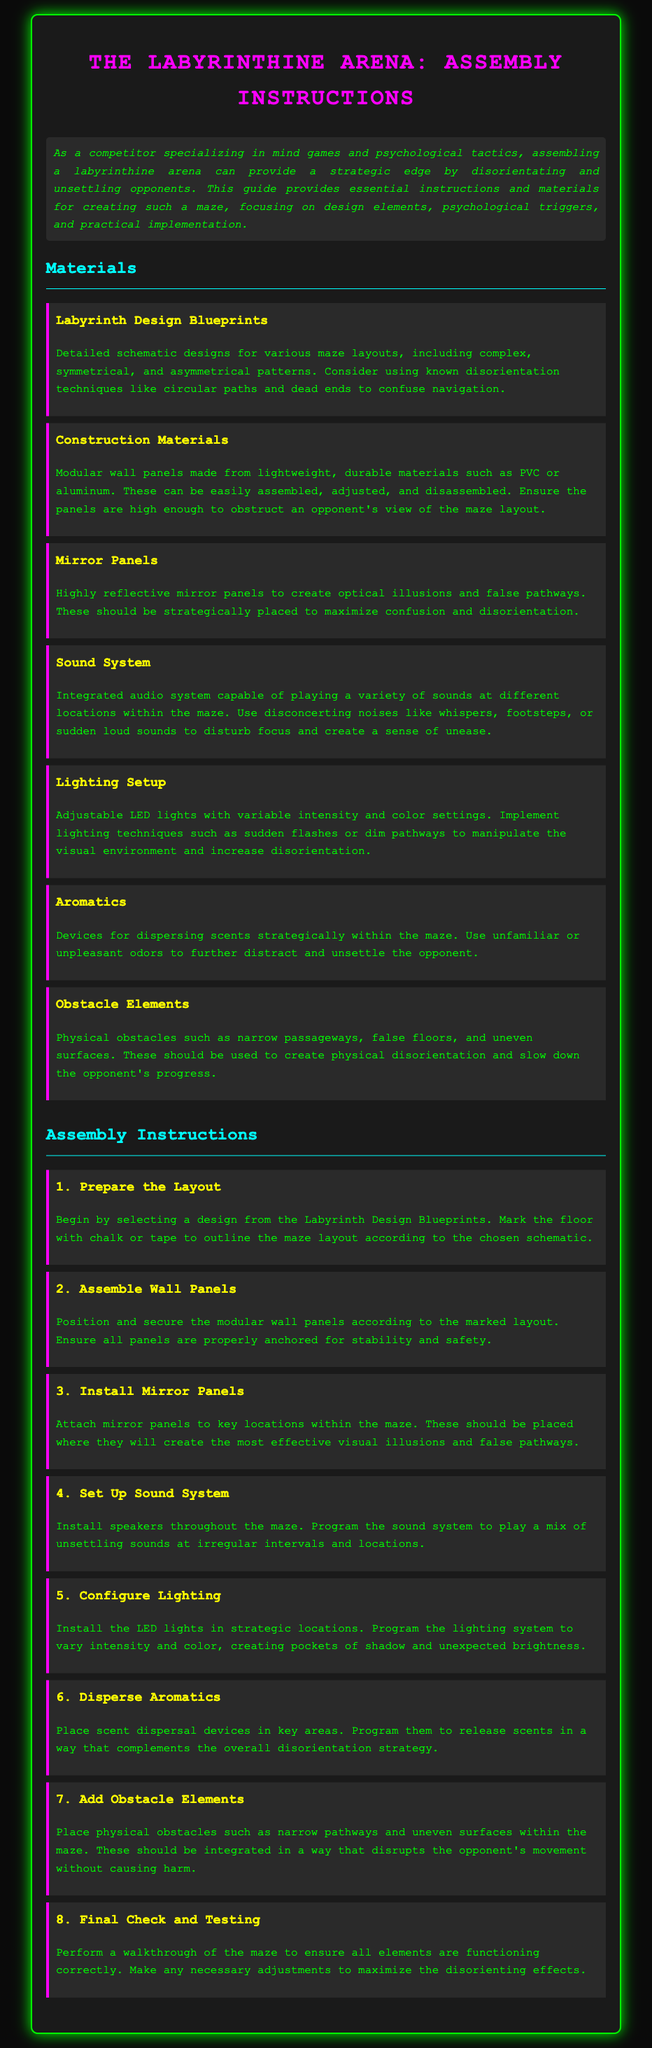What is the purpose of the labyrinthine arena? The document states that the purpose is to provide a strategic edge by disorientating and unsettling opponents.
Answer: Disorientating and unsettling opponents How many materials are listed? The document lists a total of seven materials necessary for assembly.
Answer: Seven What is the first step in the assembly instructions? The first step is to prepare the layout by selecting a design and marking the floor.
Answer: Prepare the layout What type of panels create optical illusions? The document specifies that mirror panels create optical illusions and false pathways.
Answer: Mirror panels What should the lighting setup be adjustable for? The lighting setup should be adjustable for intensity and color settings.
Answer: Intensity and color settings Which sound is suggested to disturb focus? The document suggests using disconcerting noises like whispers to disturb focus.
Answer: Whispers What should be included in the final check? The final check involves performing a walkthrough of the maze to ensure all elements are functioning correctly.
Answer: Walkthrough of the maze What should be integrated to slow down the opponent's progress? The document mentions that physical obstacles should be integrated to slow down an opponent's progress.
Answer: Physical obstacles 